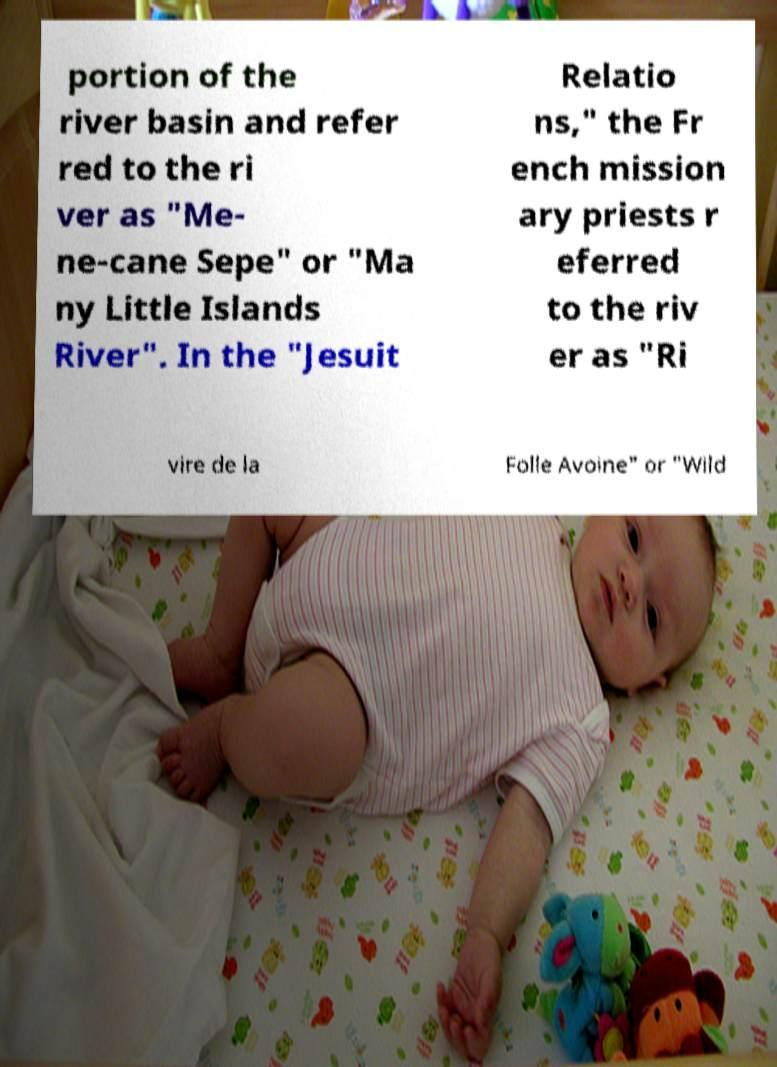Please read and relay the text visible in this image. What does it say? portion of the river basin and refer red to the ri ver as "Me- ne-cane Sepe" or "Ma ny Little Islands River". In the "Jesuit Relatio ns," the Fr ench mission ary priests r eferred to the riv er as "Ri vire de la Folle Avoine" or "Wild 